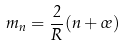Convert formula to latex. <formula><loc_0><loc_0><loc_500><loc_500>m _ { n } = \frac { 2 } { R } ( n + \sigma )</formula> 